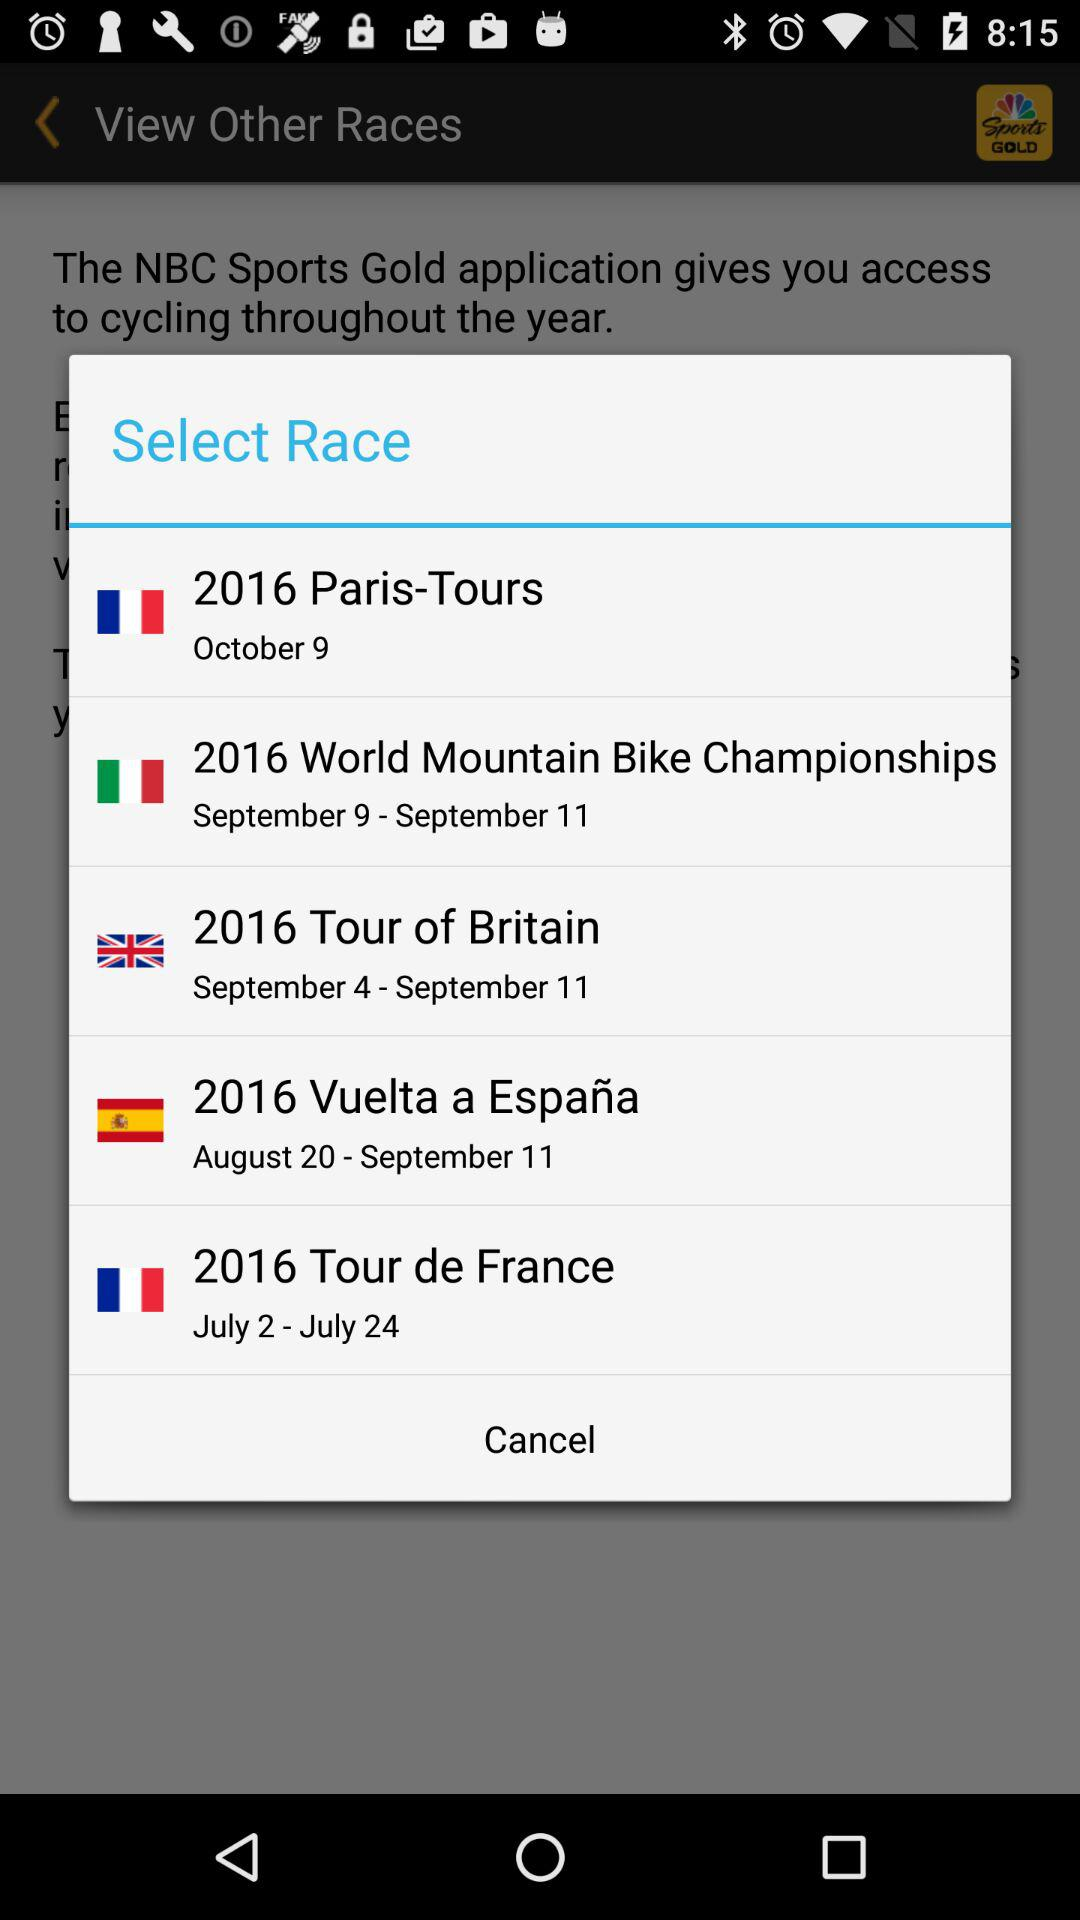What is the date of the 2016 Paris-Tours race? The date of the 2016 Paris-Tours race is October 9. 